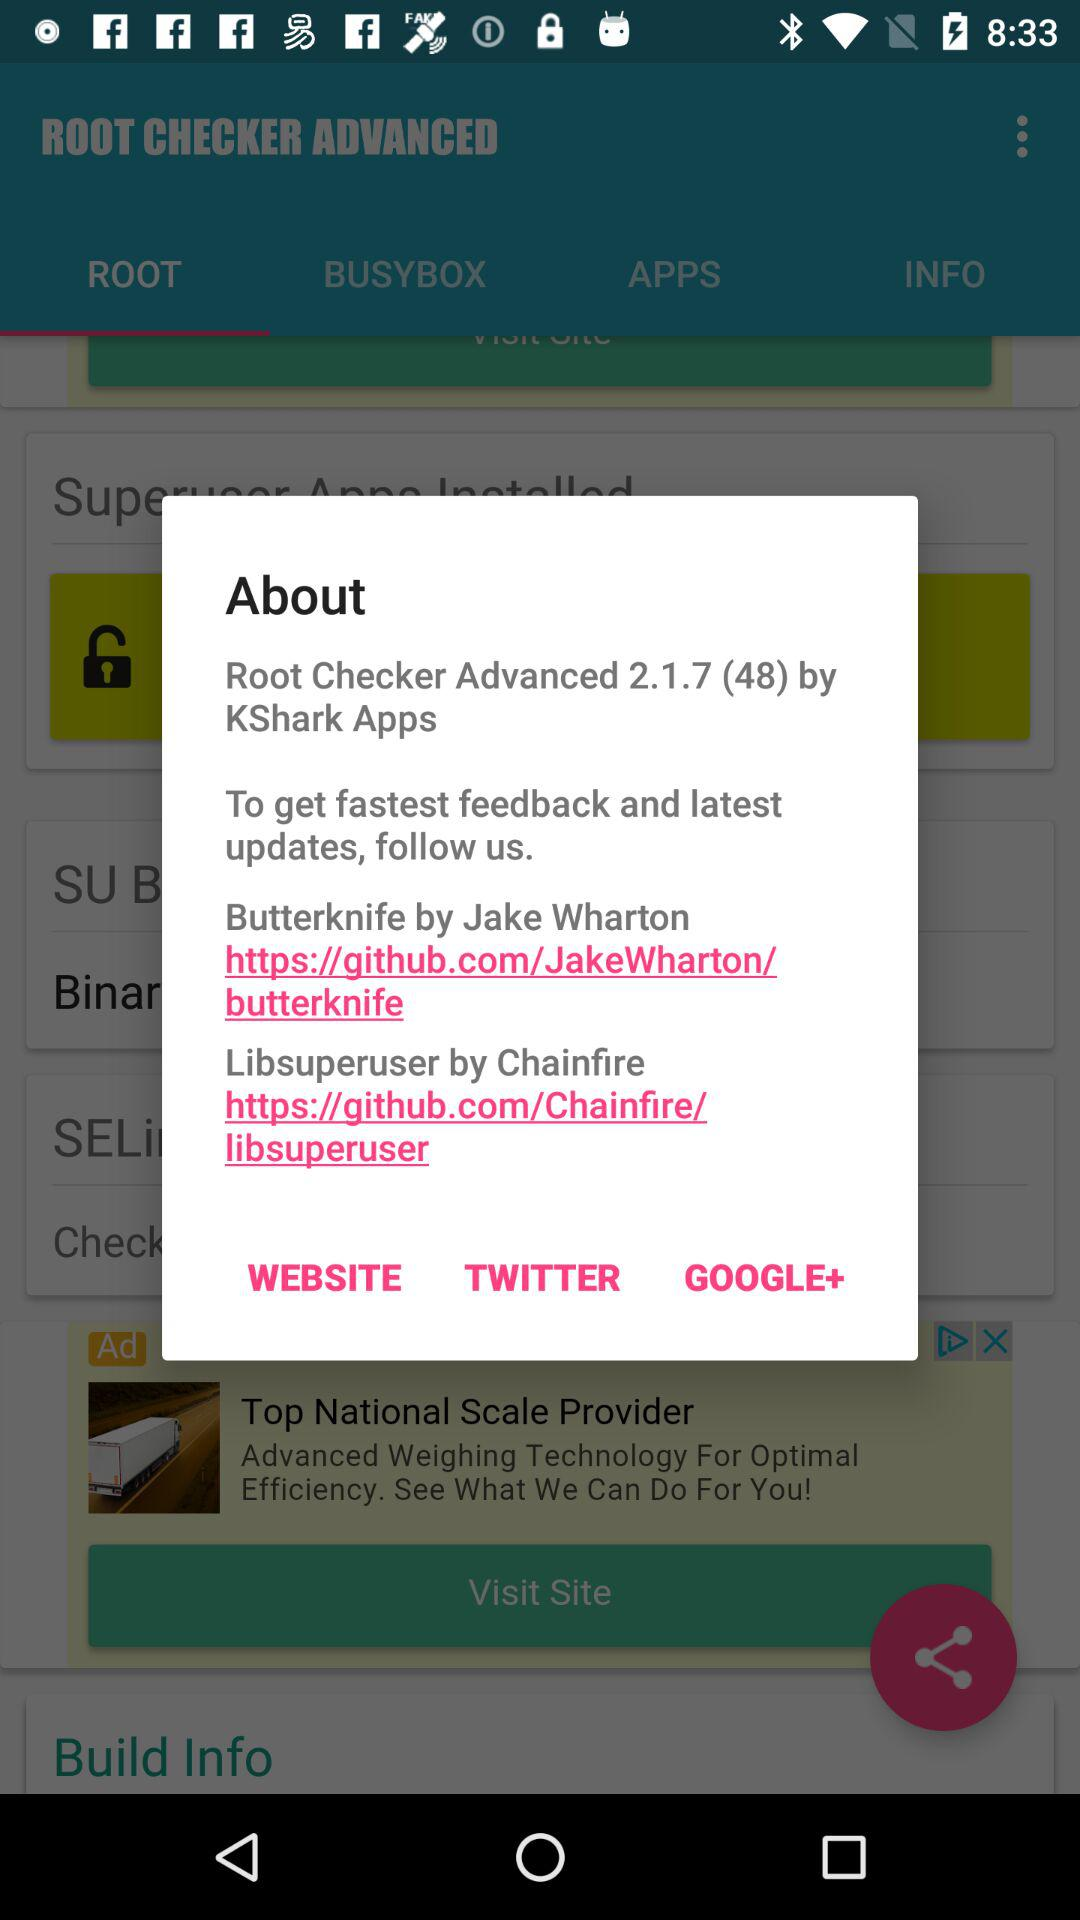What is the URL for the "Libsuperuser" by "Chainfire"? The URL for the "Libsuperuser" by "Chainfire" is https://github.com/Chainfire/libsuperuser. 